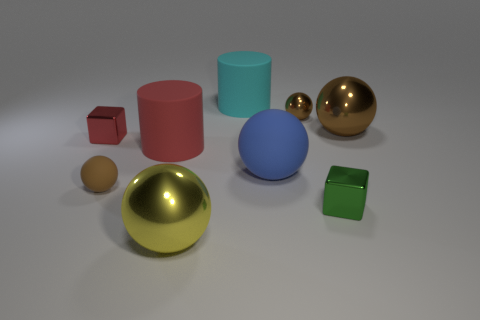How many things are behind the small red thing and in front of the tiny green cube?
Give a very brief answer. 0. How many yellow things are tiny blocks or metal things?
Make the answer very short. 1. Is the color of the cube behind the brown matte sphere the same as the big object that is left of the big yellow sphere?
Provide a short and direct response. Yes. The rubber cylinder in front of the big cyan cylinder on the right side of the shiny object to the left of the red cylinder is what color?
Offer a terse response. Red. Are there any small green blocks in front of the tiny shiny block that is on the right side of the yellow metal sphere?
Your answer should be very brief. No. Do the brown object that is in front of the blue matte sphere and the cyan matte object have the same shape?
Your answer should be very brief. No. Are there any other things that have the same shape as the tiny brown matte thing?
Your answer should be very brief. Yes. What number of cubes are cyan things or red rubber things?
Offer a terse response. 0. How many big matte objects are there?
Your response must be concise. 3. What size is the red thing in front of the small metal cube that is left of the yellow ball?
Give a very brief answer. Large. 